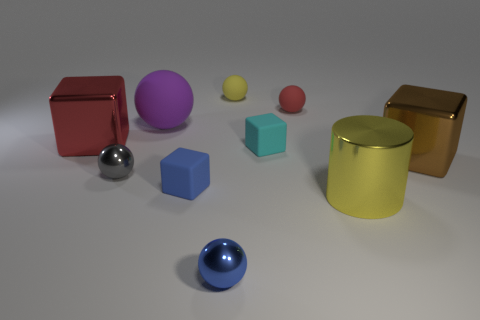There is a tiny blue object that is made of the same material as the big ball; what shape is it?
Provide a succinct answer. Cube. Is the size of the red thing to the left of the blue rubber cube the same as the big brown block?
Your response must be concise. Yes. What shape is the tiny metallic thing right of the gray metal sphere that is left of the tiny cyan thing?
Make the answer very short. Sphere. What size is the yellow thing that is in front of the yellow rubber ball that is behind the large yellow thing?
Provide a succinct answer. Large. There is a ball right of the tiny yellow matte sphere; what is its color?
Offer a very short reply. Red. There is a blue thing that is made of the same material as the large purple object; what size is it?
Your response must be concise. Small. What number of big yellow things have the same shape as the tiny gray shiny object?
Give a very brief answer. 0. There is a yellow object that is the same size as the brown shiny thing; what is its material?
Ensure brevity in your answer.  Metal. Are there any other tiny yellow things that have the same material as the small yellow thing?
Your answer should be very brief. No. What color is the metal thing that is in front of the big brown metal block and right of the tiny cyan block?
Offer a very short reply. Yellow. 